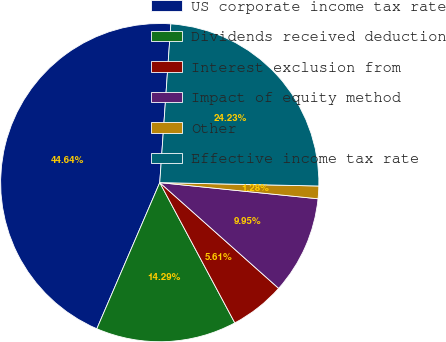Convert chart to OTSL. <chart><loc_0><loc_0><loc_500><loc_500><pie_chart><fcel>US corporate income tax rate<fcel>Dividends received deduction<fcel>Interest exclusion from<fcel>Impact of equity method<fcel>Other<fcel>Effective income tax rate<nl><fcel>44.64%<fcel>14.29%<fcel>5.61%<fcel>9.95%<fcel>1.28%<fcel>24.23%<nl></chart> 